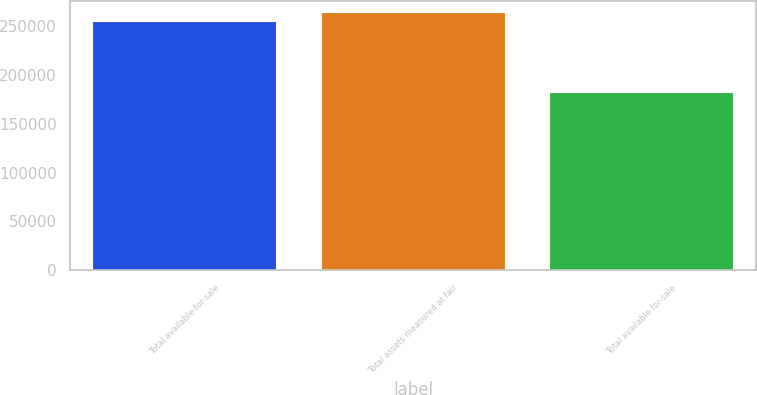<chart> <loc_0><loc_0><loc_500><loc_500><bar_chart><fcel>Total available-for-sale<fcel>Total assets measured at fair<fcel>Total available for-sale<nl><fcel>254643<fcel>263257<fcel>181865<nl></chart> 